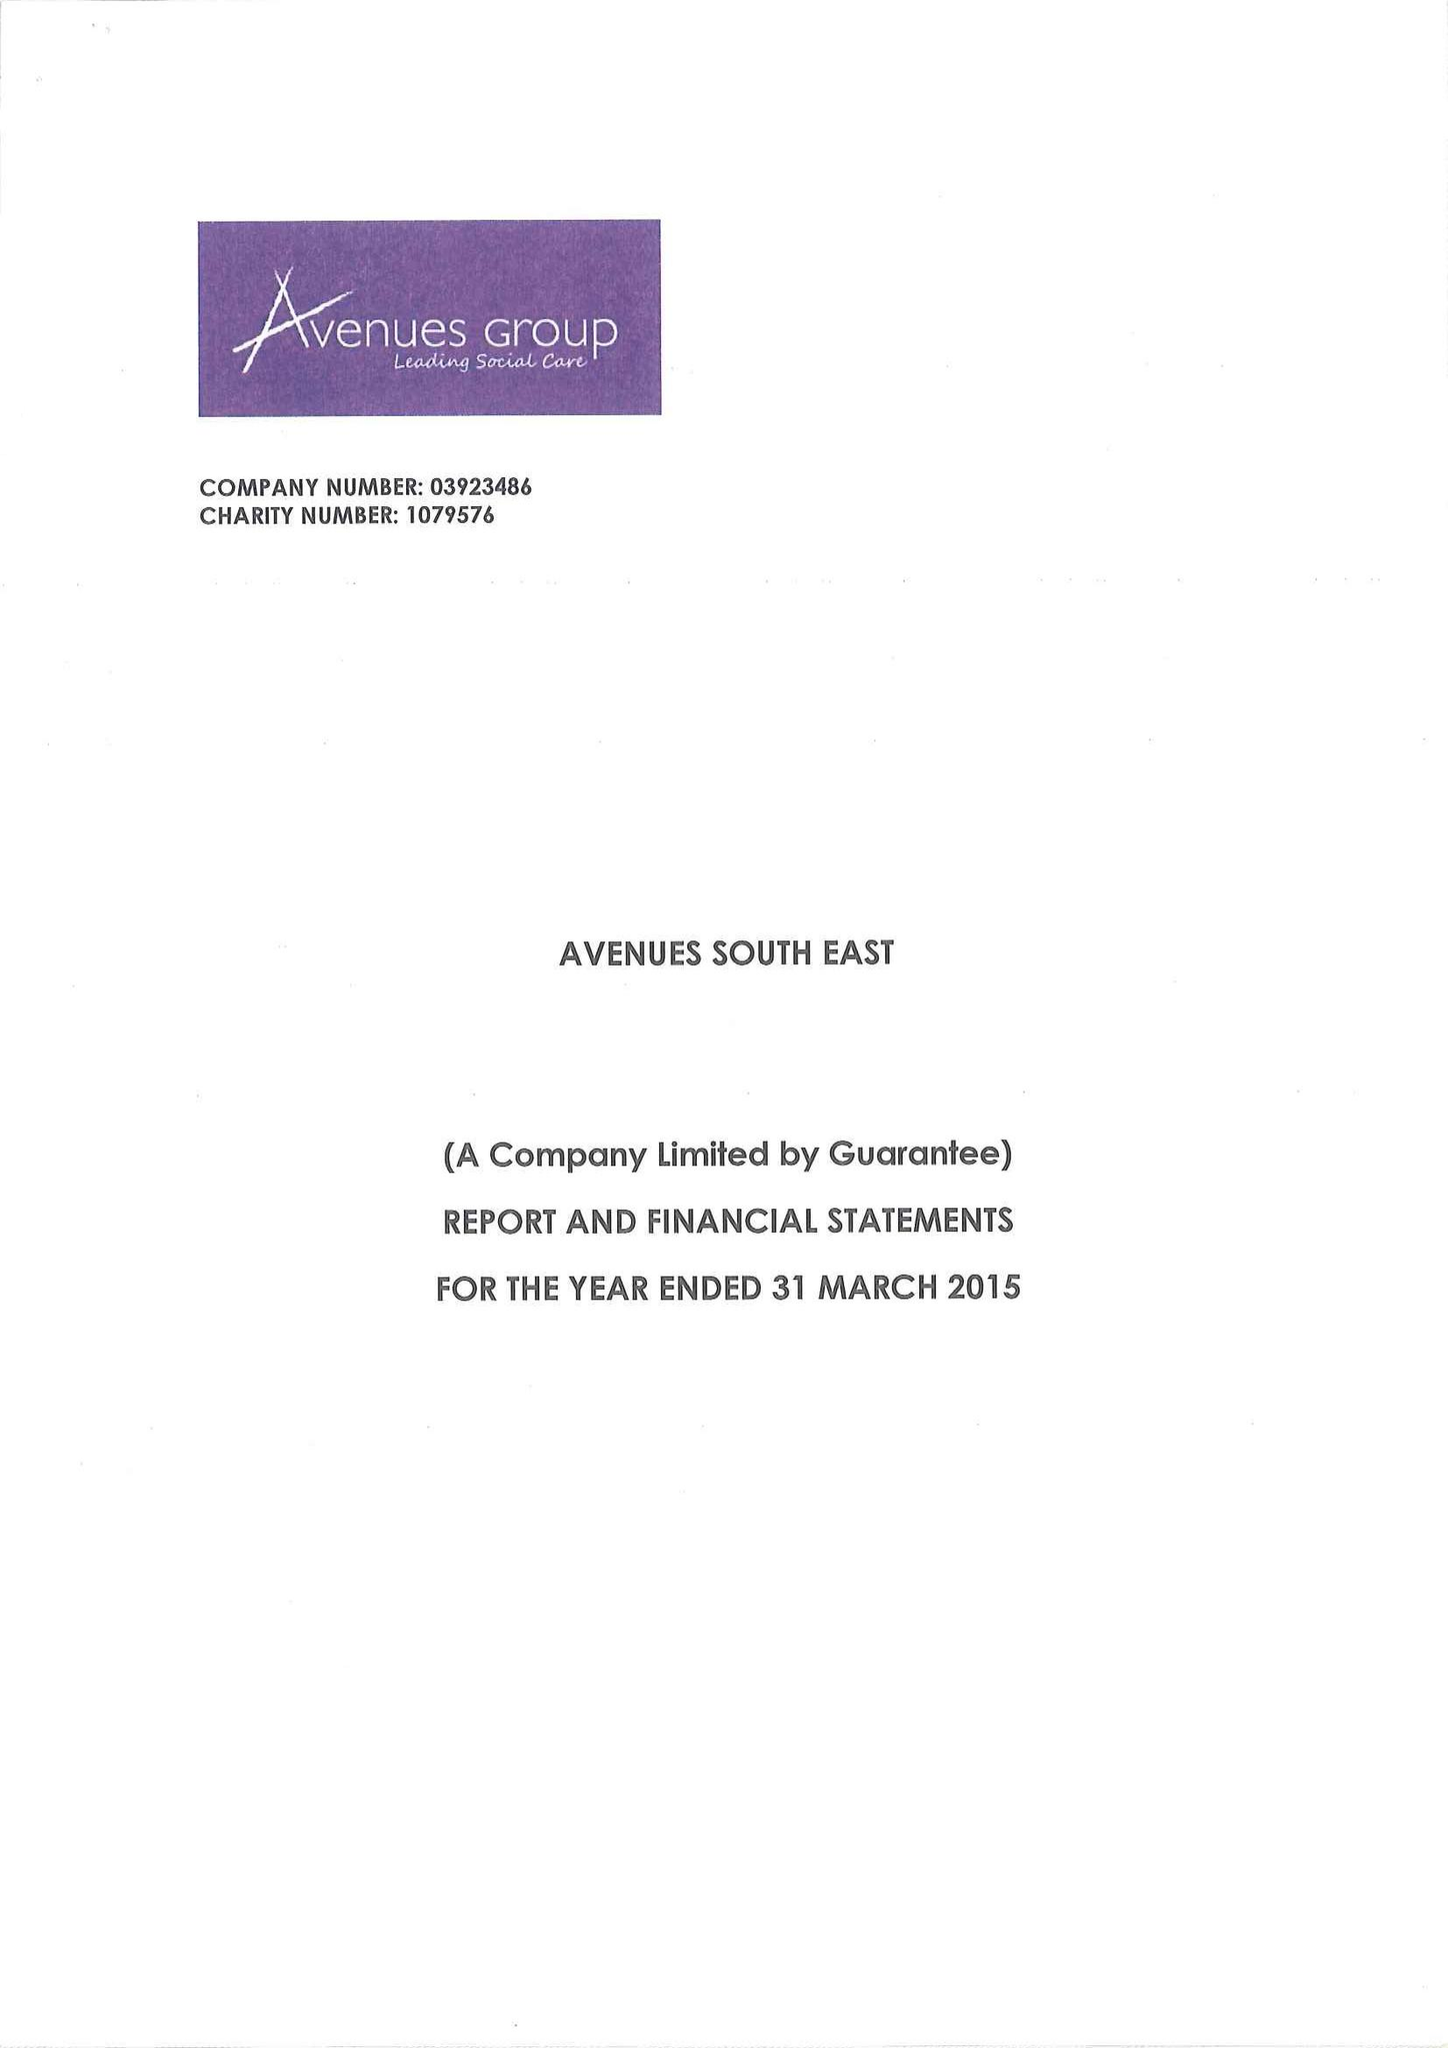What is the value for the address__postcode?
Answer the question using a single word or phrase. DA14 5TA 